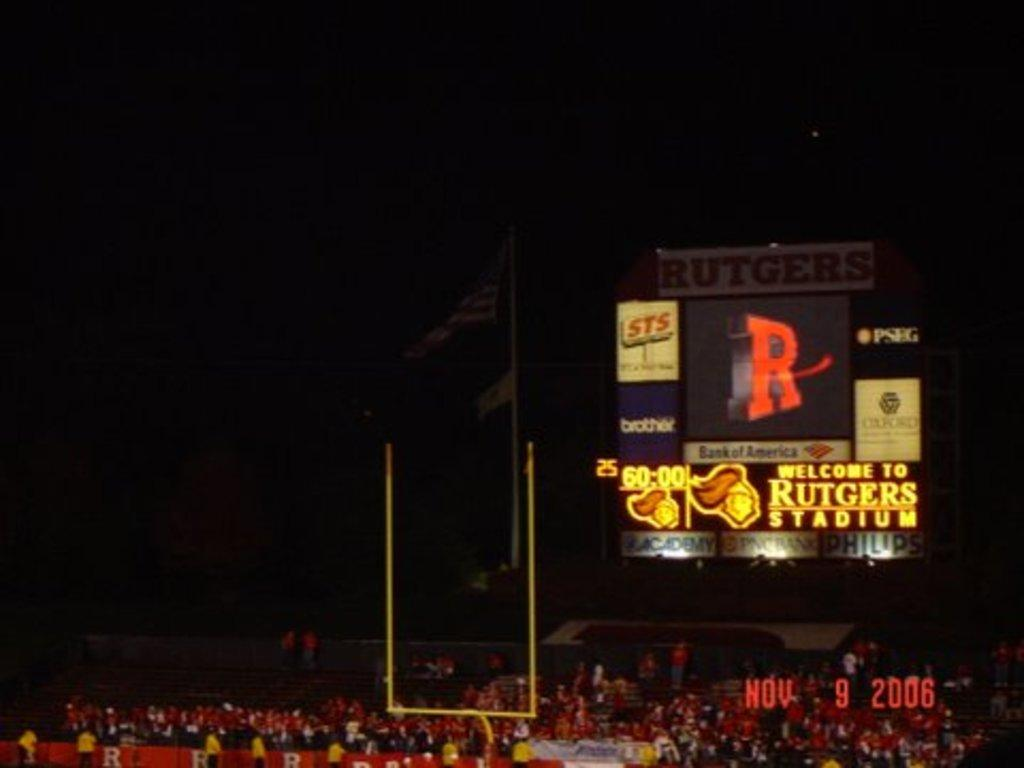Provide a one-sentence caption for the provided image. The Rutgers playing football at their home stadium. 